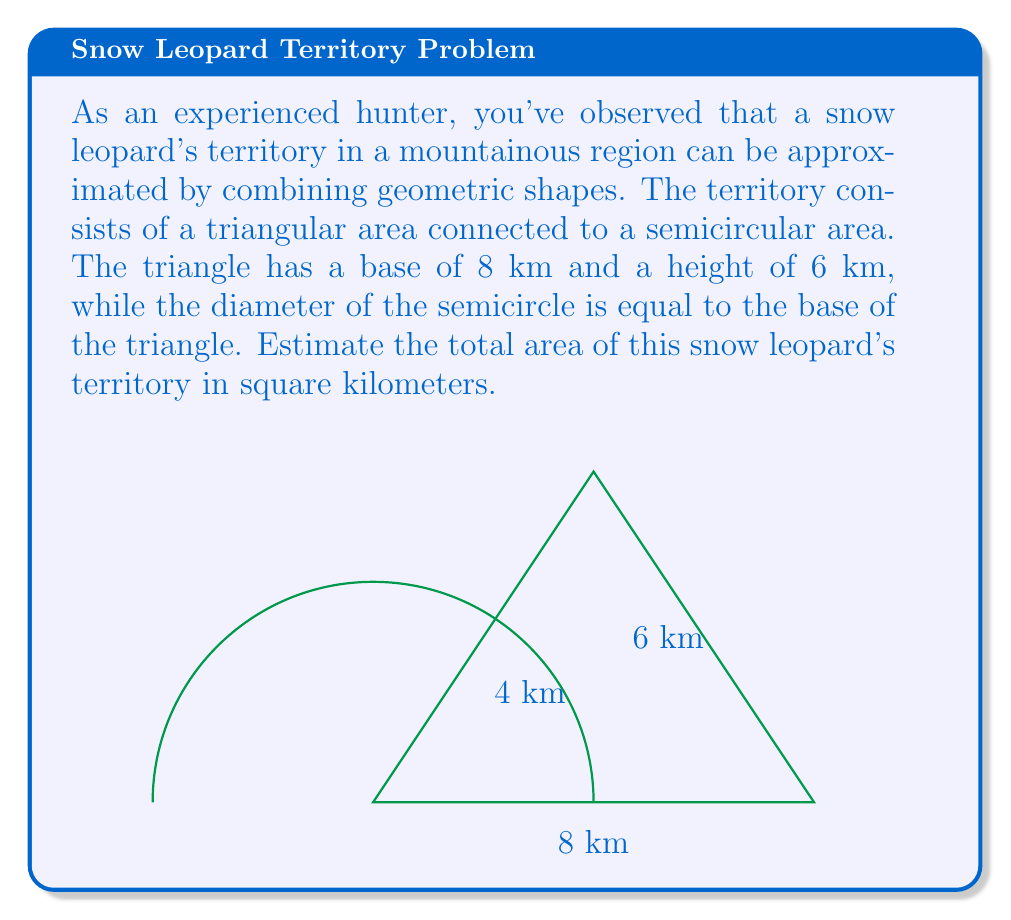Show me your answer to this math problem. To estimate the area of the snow leopard's territory, we need to calculate the areas of the triangle and the semicircle separately, then add them together.

1. Area of the triangle:
   The formula for the area of a triangle is $A = \frac{1}{2} \times base \times height$
   $$A_{triangle} = \frac{1}{2} \times 8 \times 6 = 24 \text{ km}^2$$

2. Area of the semicircle:
   The diameter of the semicircle is equal to the base of the triangle, which is 8 km.
   Therefore, the radius is 4 km.
   The formula for the area of a circle is $A = \pi r^2$
   For a semicircle, we use half of this:
   $$A_{semicircle} = \frac{1}{2} \times \pi r^2 = \frac{1}{2} \times \pi \times 4^2 = 8\pi \text{ km}^2$$

3. Total area:
   $$A_{total} = A_{triangle} + A_{semicircle} = 24 + 8\pi \text{ km}^2$$

4. Simplifying:
   $$A_{total} = 24 + 8\pi \approx 49.13 \text{ km}^2$$

Therefore, the estimated area of the snow leopard's territory is approximately 49.13 square kilometers.
Answer: $49.13 \text{ km}^2$ 